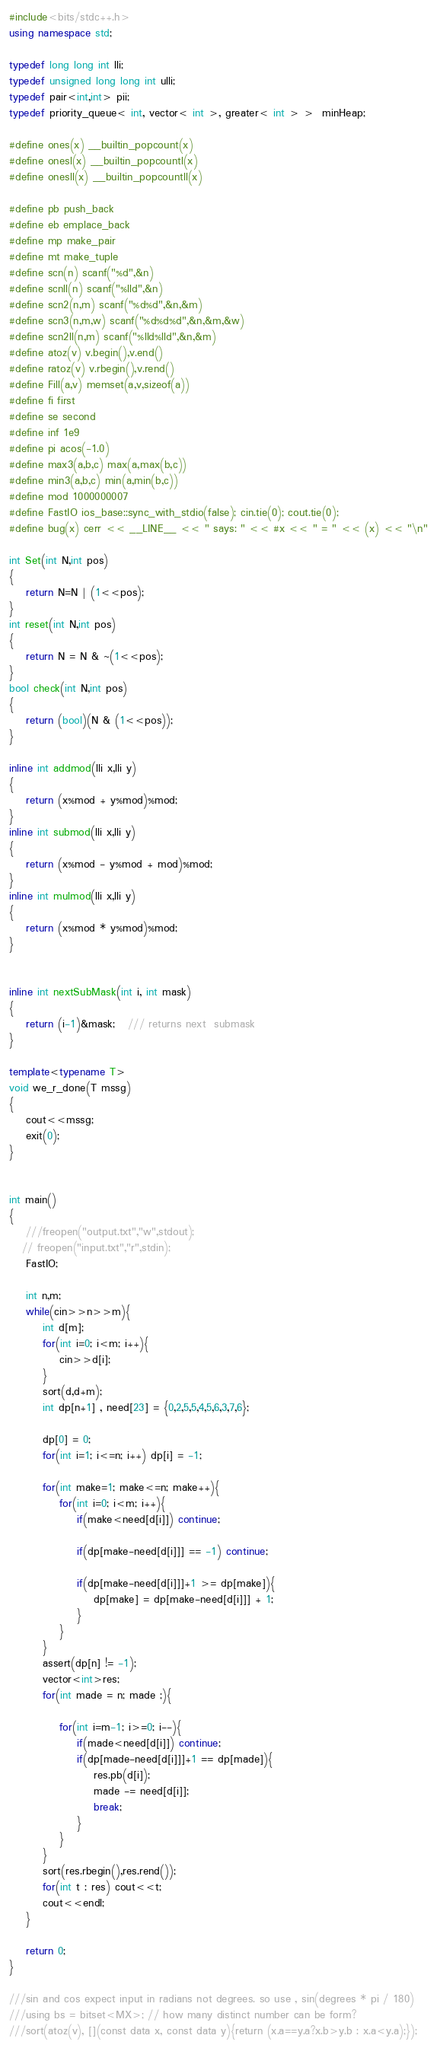<code> <loc_0><loc_0><loc_500><loc_500><_C++_>#include<bits/stdc++.h>
using namespace std;

typedef long long int lli;
typedef unsigned long long int ulli;
typedef pair<int,int> pii;
typedef priority_queue< int, vector< int >, greater< int > >  minHeap;

#define ones(x) __builtin_popcount(x)
#define onesl(x) __builtin_popcountl(x)
#define onesll(x) __builtin_popcountll(x)

#define pb push_back
#define eb emplace_back
#define mp make_pair
#define mt make_tuple
#define scn(n) scanf("%d",&n)
#define scnll(n) scanf("%lld",&n)
#define scn2(n,m) scanf("%d%d",&n,&m)
#define scn3(n,m,w) scanf("%d%d%d",&n,&m,&w)
#define scn2ll(n,m) scanf("%lld%lld",&n,&m)
#define atoz(v) v.begin(),v.end()
#define ratoz(v) v.rbegin(),v.rend()
#define Fill(a,v) memset(a,v,sizeof(a))
#define fi first
#define se second
#define inf 1e9
#define pi acos(-1.0)
#define max3(a,b,c) max(a,max(b,c))
#define min3(a,b,c) min(a,min(b,c))
#define mod 1000000007
#define FastIO ios_base::sync_with_stdio(false); cin.tie(0); cout.tie(0);
#define bug(x) cerr << __LINE__ << " says: " << #x << " = " << (x) << "\n"

int Set(int N,int pos)
{
    return N=N | (1<<pos);
}
int reset(int N,int pos)
{
    return N = N & ~(1<<pos);
}
bool check(int N,int pos)
{
    return (bool)(N & (1<<pos));
}

inline int addmod(lli x,lli y)
{
    return (x%mod + y%mod)%mod;
}
inline int submod(lli x,lli y)
{
    return (x%mod - y%mod + mod)%mod;
}
inline int mulmod(lli x,lli y)
{
    return (x%mod * y%mod)%mod;
}


inline int nextSubMask(int i, int mask)
{
    return (i-1)&mask;   /// returns next  submask
}

template<typename T>
void we_r_done(T mssg)
{
    cout<<mssg;
    exit(0);
}


int main()
{
    ///freopen("output.txt","w",stdout);
   // freopen("input.txt","r",stdin);
    FastIO;

    int n,m;
    while(cin>>n>>m){
        int d[m];
        for(int i=0; i<m; i++){
            cin>>d[i];
        }
        sort(d,d+m);
        int dp[n+1] , need[23] = {0,2,5,5,4,5,6,3,7,6};

        dp[0] = 0;
        for(int i=1; i<=n; i++) dp[i] = -1;

        for(int make=1; make<=n; make++){
            for(int i=0; i<m; i++){
                if(make<need[d[i]]) continue;

                if(dp[make-need[d[i]]] == -1) continue;

                if(dp[make-need[d[i]]]+1 >= dp[make]){
                    dp[make] = dp[make-need[d[i]]] + 1;
                }
            }
        }
        assert(dp[n] != -1);
        vector<int>res;
        for(int made = n; made ;){

            for(int i=m-1; i>=0; i--){
                if(made<need[d[i]]) continue;
                if(dp[made-need[d[i]]]+1 == dp[made]){
                    res.pb(d[i]);
                    made -= need[d[i]];
                    break;
                }
            }
        }
        sort(res.rbegin(),res.rend());
        for(int t : res) cout<<t;
        cout<<endl;
    }

    return 0;
}

///sin and cos expect input in radians not degrees. so use , sin(degrees * pi / 180)
///using bs = bitset<MX>; // how many distinct number can be form?
///sort(atoz(v), [](const data x, const data y){return (x.a==y.a?x.b>y.b : x.a<y.a);});
</code> 